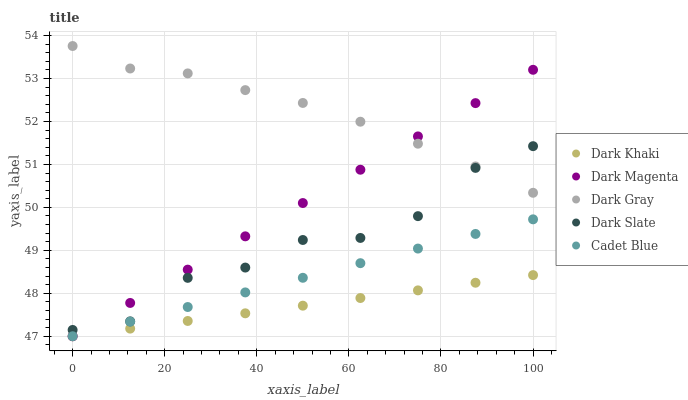Does Dark Khaki have the minimum area under the curve?
Answer yes or no. Yes. Does Dark Gray have the maximum area under the curve?
Answer yes or no. Yes. Does Cadet Blue have the minimum area under the curve?
Answer yes or no. No. Does Cadet Blue have the maximum area under the curve?
Answer yes or no. No. Is Dark Khaki the smoothest?
Answer yes or no. Yes. Is Dark Slate the roughest?
Answer yes or no. Yes. Is Dark Gray the smoothest?
Answer yes or no. No. Is Dark Gray the roughest?
Answer yes or no. No. Does Dark Khaki have the lowest value?
Answer yes or no. Yes. Does Dark Gray have the lowest value?
Answer yes or no. No. Does Dark Gray have the highest value?
Answer yes or no. Yes. Does Cadet Blue have the highest value?
Answer yes or no. No. Is Cadet Blue less than Dark Gray?
Answer yes or no. Yes. Is Dark Slate greater than Dark Khaki?
Answer yes or no. Yes. Does Cadet Blue intersect Dark Khaki?
Answer yes or no. Yes. Is Cadet Blue less than Dark Khaki?
Answer yes or no. No. Is Cadet Blue greater than Dark Khaki?
Answer yes or no. No. Does Cadet Blue intersect Dark Gray?
Answer yes or no. No. 